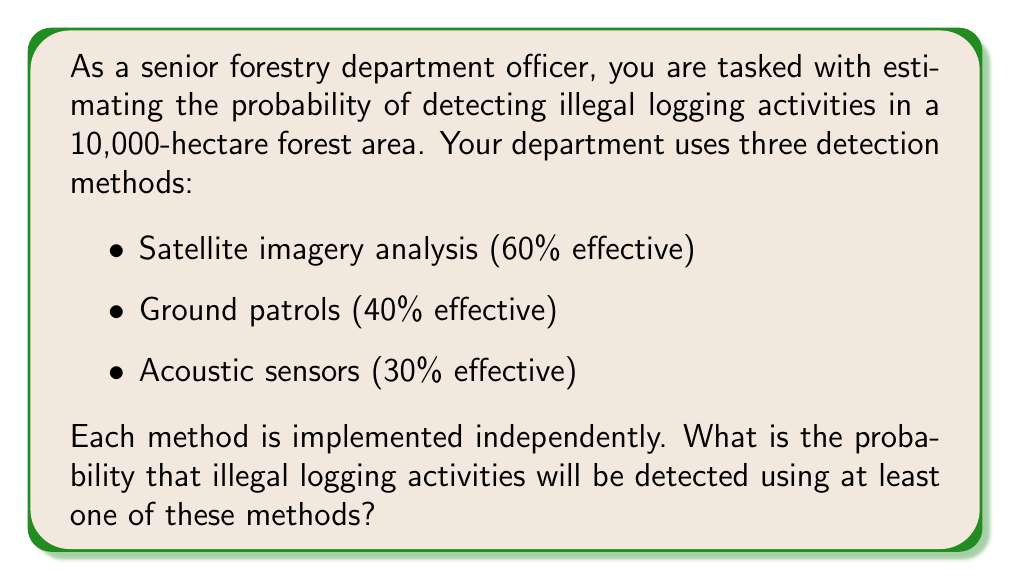What is the answer to this math problem? To solve this problem, we'll use the concept of probability of the union of events. Let's approach this step-by-step:

1. Define the events:
   A: Detection by satellite imagery
   B: Detection by ground patrols
   C: Detection by acoustic sensors

2. Given probabilities:
   P(A) = 0.60
   P(B) = 0.40
   P(C) = 0.30

3. We want to find P(A ∪ B ∪ C), which is the probability of detection by at least one method.

4. Using the principle of inclusion-exclusion for three events:

   $$P(A ∪ B ∪ C) = P(A) + P(B) + P(C) - P(A ∩ B) - P(A ∩ C) - P(B ∩ C) + P(A ∩ B ∩ C)$$

5. Since the methods are independent, we can calculate the intersections as:
   
   $$P(A ∩ B) = P(A) × P(B) = 0.60 × 0.40 = 0.24$$
   $$P(A ∩ C) = P(A) × P(C) = 0.60 × 0.30 = 0.18$$
   $$P(B ∩ C) = P(B) × P(C) = 0.40 × 0.30 = 0.12$$
   $$P(A ∩ B ∩ C) = P(A) × P(B) × P(C) = 0.60 × 0.40 × 0.30 = 0.072$$

6. Now, let's substitute these values into the formula:

   $$P(A ∪ B ∪ C) = 0.60 + 0.40 + 0.30 - 0.24 - 0.18 - 0.12 + 0.072$$
   
   $$P(A ∪ B ∪ C) = 1.30 - 0.54 + 0.072$$
   
   $$P(A ∪ B ∪ C) = 0.832$$

7. Convert to a percentage:
   0.832 × 100% = 83.2%
Answer: The probability of detecting illegal logging activities using at least one of the three methods is 83.2%. 